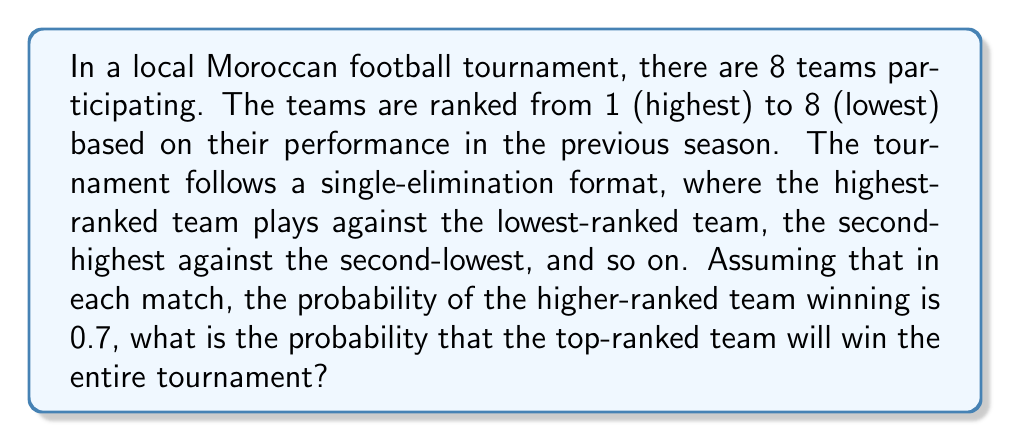Give your solution to this math problem. Let's approach this step-by-step:

1) In a single-elimination tournament with 8 teams, there are three rounds: quarter-finals, semi-finals, and the final.

2) For the top-ranked team to win the tournament, they need to win all three of their matches.

3) In the quarter-finals, the top-ranked team will play against the 8th ranked team. The probability of winning this match is 0.7.

4) In the semi-finals, if they win, they will play against either the 4th or 5th ranked team (as these teams play each other in the quarter-finals). The probability of winning against either of these teams is also 0.7.

5) In the finals, if they make it, they could face any of the teams ranked 2, 3, 6, or 7. Again, the probability of winning against any of these teams is 0.7.

6) To calculate the overall probability of winning the tournament, we need to multiply the probabilities of winning each match:

   $$P(\text{winning tournament}) = P(\text{winning QF}) \times P(\text{winning SF}) \times P(\text{winning F})$$

   $$P(\text{winning tournament}) = 0.7 \times 0.7 \times 0.7$$

   $$P(\text{winning tournament}) = 0.7^3 = 0.343$$

Therefore, the probability of the top-ranked team winning the entire tournament is approximately 0.343 or 34.3%.
Answer: 0.343 or 34.3% 